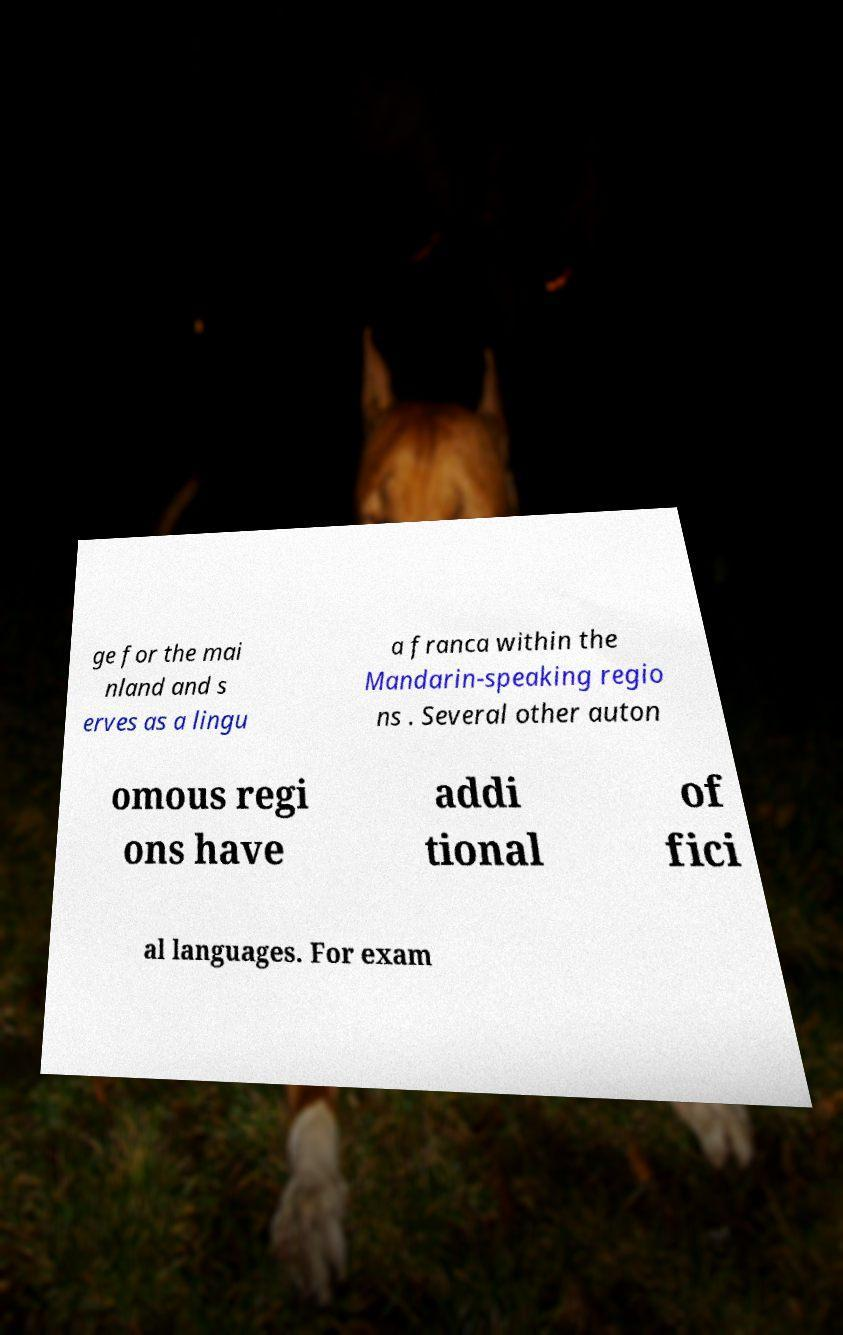Could you assist in decoding the text presented in this image and type it out clearly? ge for the mai nland and s erves as a lingu a franca within the Mandarin-speaking regio ns . Several other auton omous regi ons have addi tional of fici al languages. For exam 